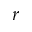Convert formula to latex. <formula><loc_0><loc_0><loc_500><loc_500>r</formula> 